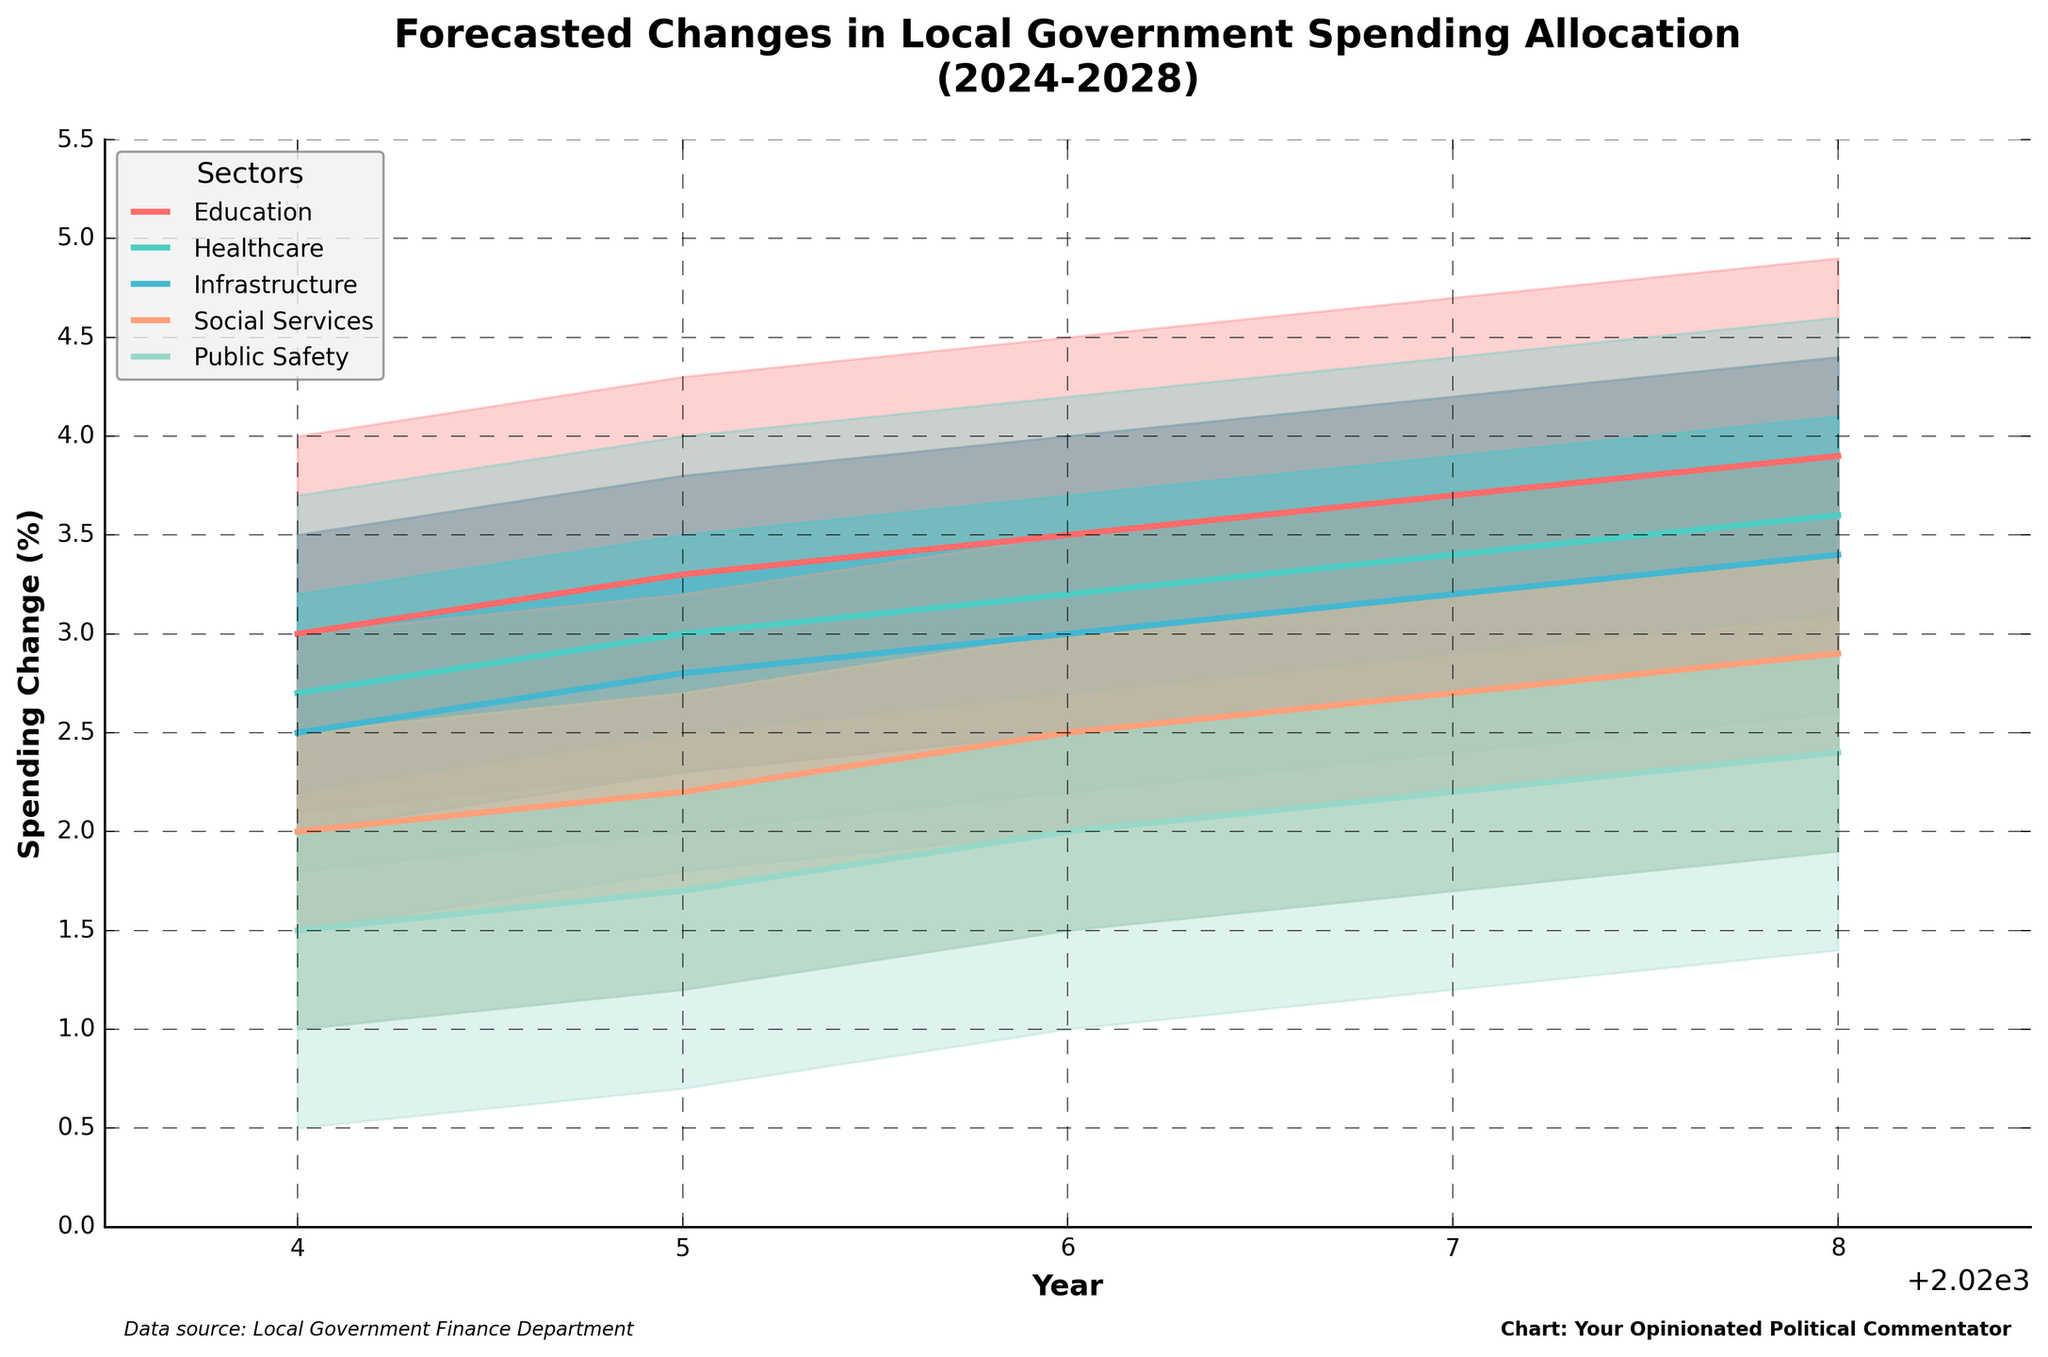Which sector is predicted to have the highest spending change in 2028 according to the median forecast? By looking at the median forecast (P50) line for each sector in 2028, we identify that Education has a P50 value of 3.9, Healthcare has 3.6, Infrastructure has 3.4, Social Services has 2.9, and Public Safety has 2.4. The highest median forecast value is for Education.
Answer: Education What's the lowest spending change predicted for Social Services in 2027 within the 80% prediction interval? The 80% prediction interval is defined by the range between P10 and P90. For Social Services in 2027, P10 is 1.7. Thus, the lowest spending change predicted for Social Services in 2027 within the 80% prediction interval is 1.7.
Answer: 1.7 What is the range of the forecasted spending change for Public Safety in 2025? The range of forecasted spending change is given by the difference between P90 and P10. For Public Safety in 2025, P90 is 2.7 and P10 is 0.7. The range is calculated as 2.7 - 0.7 = 2.0.
Answer: 2.0 Which year shows the largest median forecasted spending change for Infrastructure? By examining the P50 values for Infrastructure across the years, we see 2.5 in 2024, 2.8 in 2025, 3.0 in 2026, 3.2 in 2027, and 3.4 in 2028. The largest median forecasted spending change is 3.4 in 2028.
Answer: 2028 How does the median forecasted spending change for Education in 2026 compare to that for Healthcare in 2028? The median forecasted spending change (P50) for Education in 2026 is 3.5. For Healthcare in 2028, it is 3.6. Comparing these values, Healthcare in 2028 has a slightly higher median forecasted spending change than Education in 2026.
Answer: Healthcare in 2028 What is the average P75 value for Education from 2024 to 2028? The P75 values for Education from 2024 to 2028 are 3.5, 3.8, 4.0, 4.2, and 4.4 respectively. Adding these values gives 3.5 + 3.8 + 4.0 + 4.2 + 4.4 = 19.9. The average is then calculated by dividing by the number of values (5), resulting in 19.9 / 5 = 3.98.
Answer: 3.98 Which sector shows the least variation in forecasted spending change in 2024 as indicated by the width of the prediction intervals (P90 - P10)? Calculating the width of the prediction intervals for each sector in 2024, we get the following: Education (4.0 - 2.1 = 1.9), Healthcare (3.7 - 1.8 = 1.9), Infrastructure (3.5 - 1.5 = 2.0), Social Services (3.0 - 1.0 = 2.0), Public Safety (2.5 - 0.5 = 2.0). Both Education and Healthcare have the smallest width of 1.9.
Answer: Education and Healthcare Is there a sector that consistently shows an increasing median forecasted spending change every year from 2024 to 2028? By examining the median forecast (P50) values for each year from 2024 to 2028 for all sectors, Education shows P50 values of 3.0, 3.3, 3.5, 3.7, 3.9. The values consistently increase each year.
Answer: Education Between which two consecutive years does Infrastructure see the largest increase in median forecasted spending change? Reviewing the median forecast (P50) values for Infrastructure from 2024 to 2028, the values are 2.5, 2.8, 3.0, 3.2, and 3.4. The change from 2024 to 2025 is 0.3, 2025 to 2026 is 0.2, 2026 to 2027 is 0.2, and 2027 to 2028 is 0.2. The largest increase is 0.3, between 2024 and 2025.
Answer: 2024 and 2025 